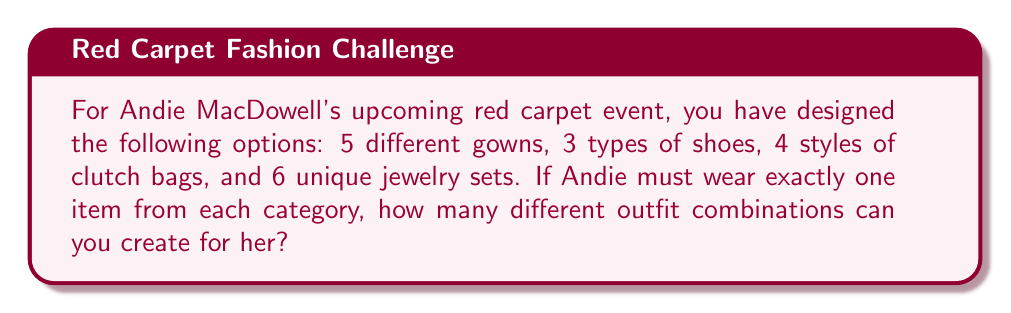Give your solution to this math problem. To solve this problem, we'll use the multiplication principle of counting. This principle states that if we have a sequence of choices, and the number of options for each choice is independent of the other choices, then the total number of possible outcomes is the product of the number of options for each choice.

Let's break down the choices:
1. Gowns: 5 options
2. Shoes: 3 options
3. Clutch bags: 4 options
4. Jewelry sets: 6 options

For each complete outfit, Andie must choose:
- 1 gown out of 5
- 1 pair of shoes out of 3
- 1 clutch bag out of 4
- 1 jewelry set out of 6

The number of ways to make each choice is independent of the others. Therefore, we multiply these numbers together:

$$ \text{Total combinations} = 5 \times 3 \times 4 \times 6 $$

$$ = 360 $$

This calculation gives us the total number of unique outfit combinations possible for Andie MacDowell's red carpet event.
Answer: $360$ different outfit combinations 